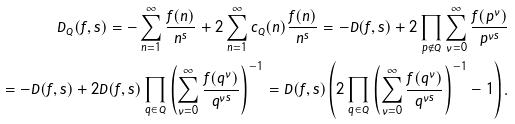<formula> <loc_0><loc_0><loc_500><loc_500>D _ { Q } ( f , s ) = - \sum _ { n = 1 } ^ { \infty } \frac { f ( n ) } { n ^ { s } } + 2 \sum _ { n = 1 } ^ { \infty } c _ { Q } ( n ) \frac { f ( n ) } { n ^ { s } } = - D ( f , s ) + 2 \prod _ { p \notin Q } \sum _ { \nu = 0 } ^ { \infty } \frac { f ( p ^ { \nu } ) } { p ^ { \nu s } } \\ = - D ( f , s ) + 2 D ( f , s ) \prod _ { q \in Q } \left ( \sum _ { \nu = 0 } ^ { \infty } \frac { f ( q ^ { \nu } ) } { q ^ { \nu s } } \right ) ^ { - 1 } = D ( f , s ) \left ( 2 \prod _ { q \in Q } \left ( \sum _ { \nu = 0 } ^ { \infty } \frac { f ( q ^ { \nu } ) } { q ^ { \nu s } } \right ) ^ { - 1 } - 1 \right ) .</formula> 